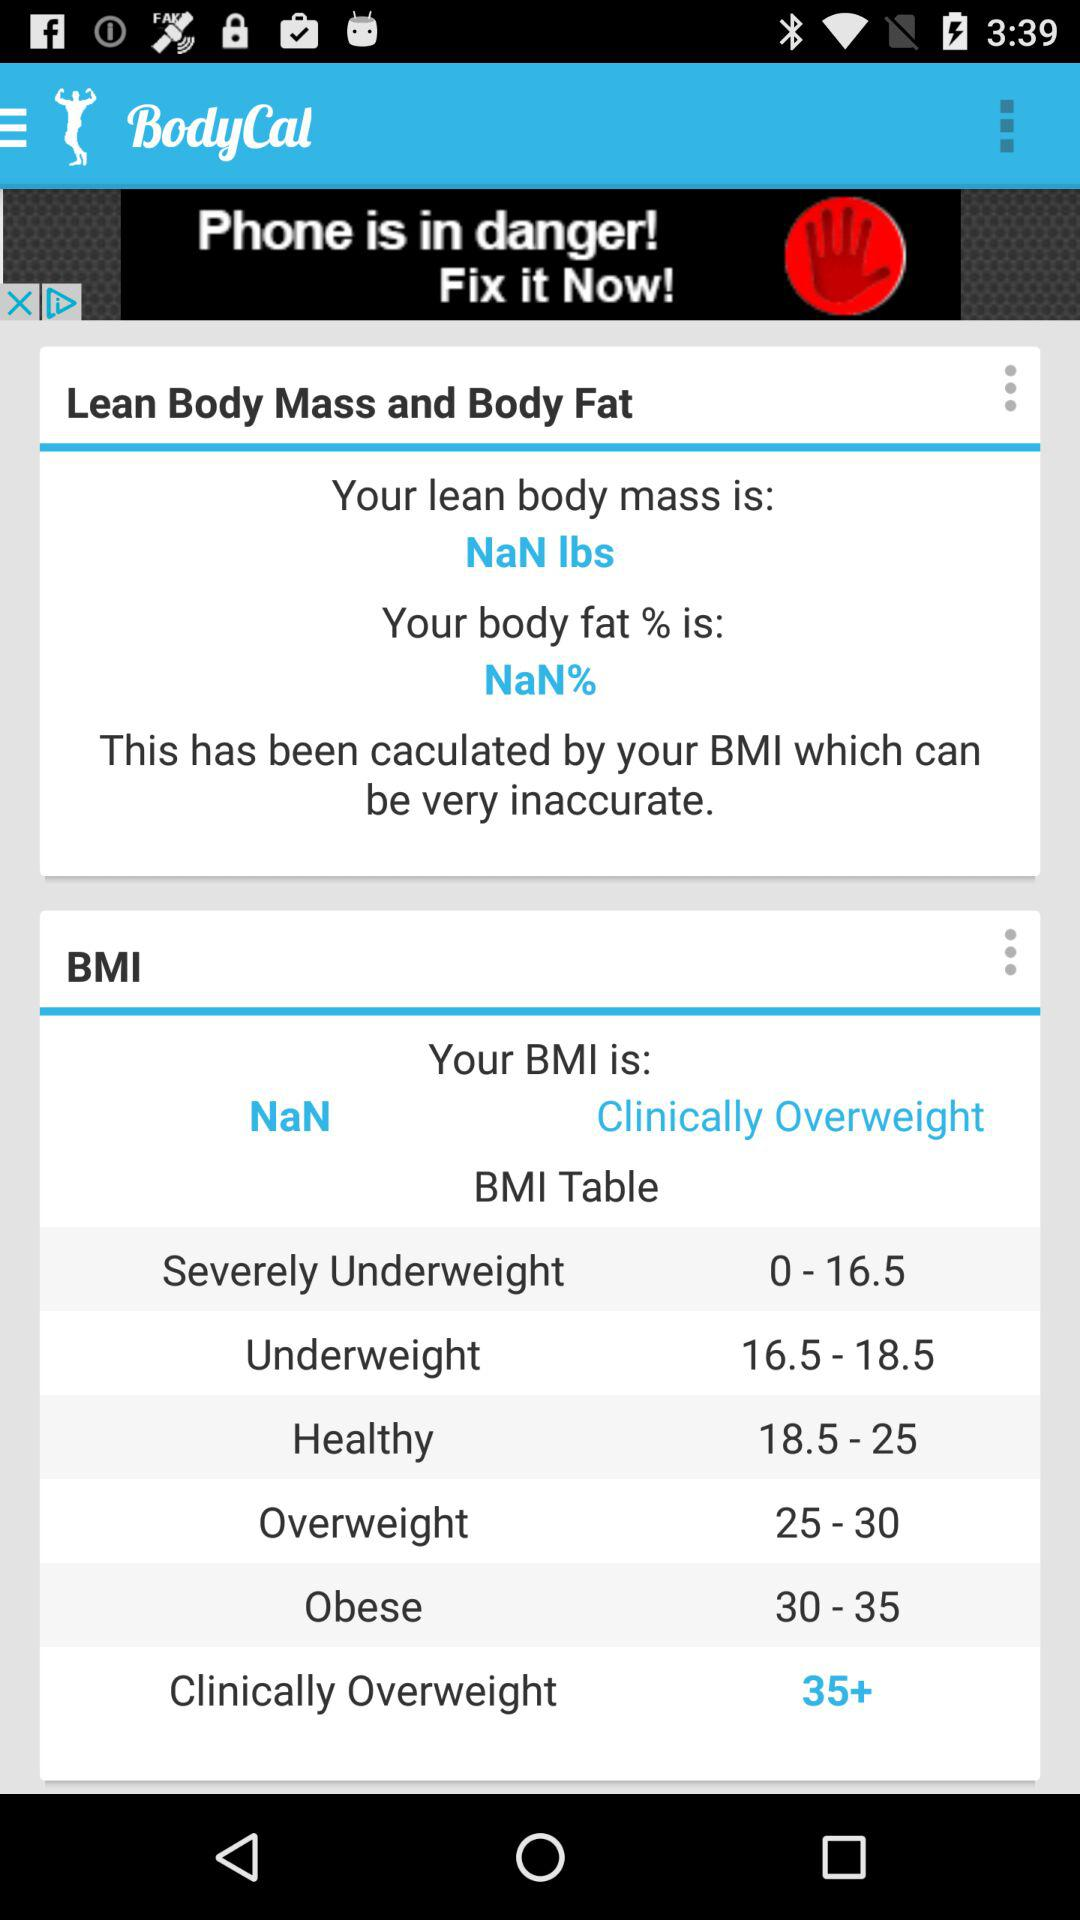What is the BMI range for Clinically Overweight?
Answer the question using a single word or phrase. 35+ 